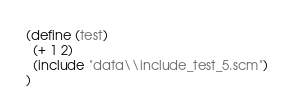<code> <loc_0><loc_0><loc_500><loc_500><_Scheme_>
(define (test)  
  (+ 1 2)
  (include "data\\include_test_5.scm")
)
</code> 